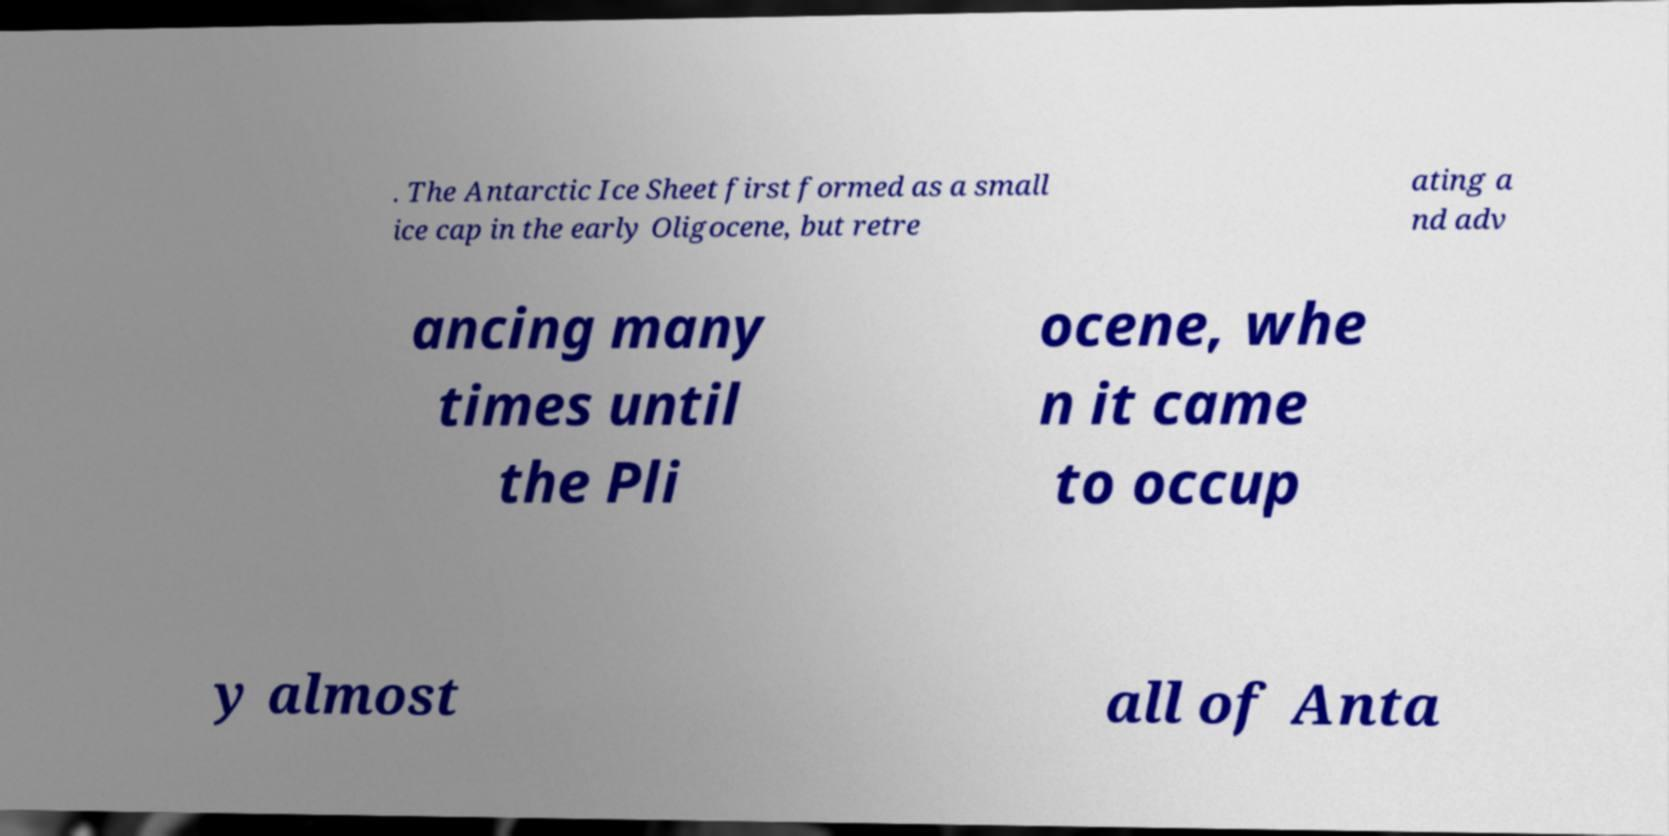Please read and relay the text visible in this image. What does it say? . The Antarctic Ice Sheet first formed as a small ice cap in the early Oligocene, but retre ating a nd adv ancing many times until the Pli ocene, whe n it came to occup y almost all of Anta 